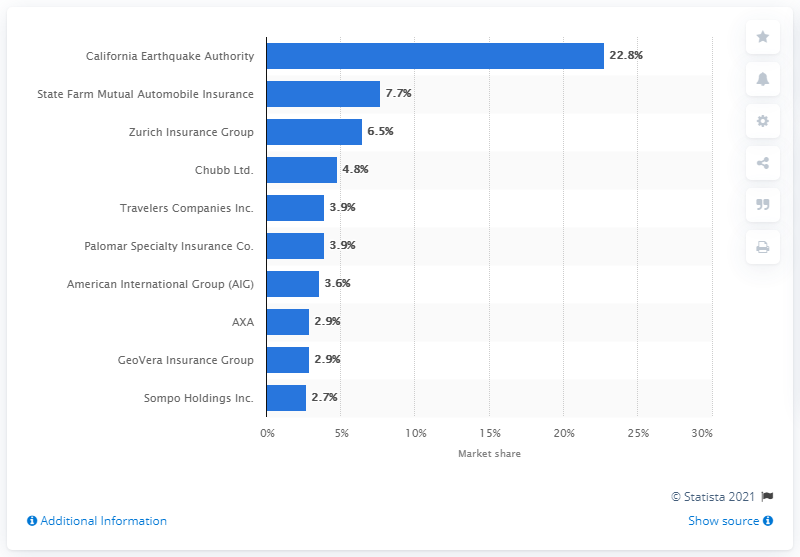Indicate a few pertinent items in this graphic. In 2019, the California Earthquake Authority held a market share of 22.8%. The California Earthquake Authority had a market share of 22.8 percent in 2019. 